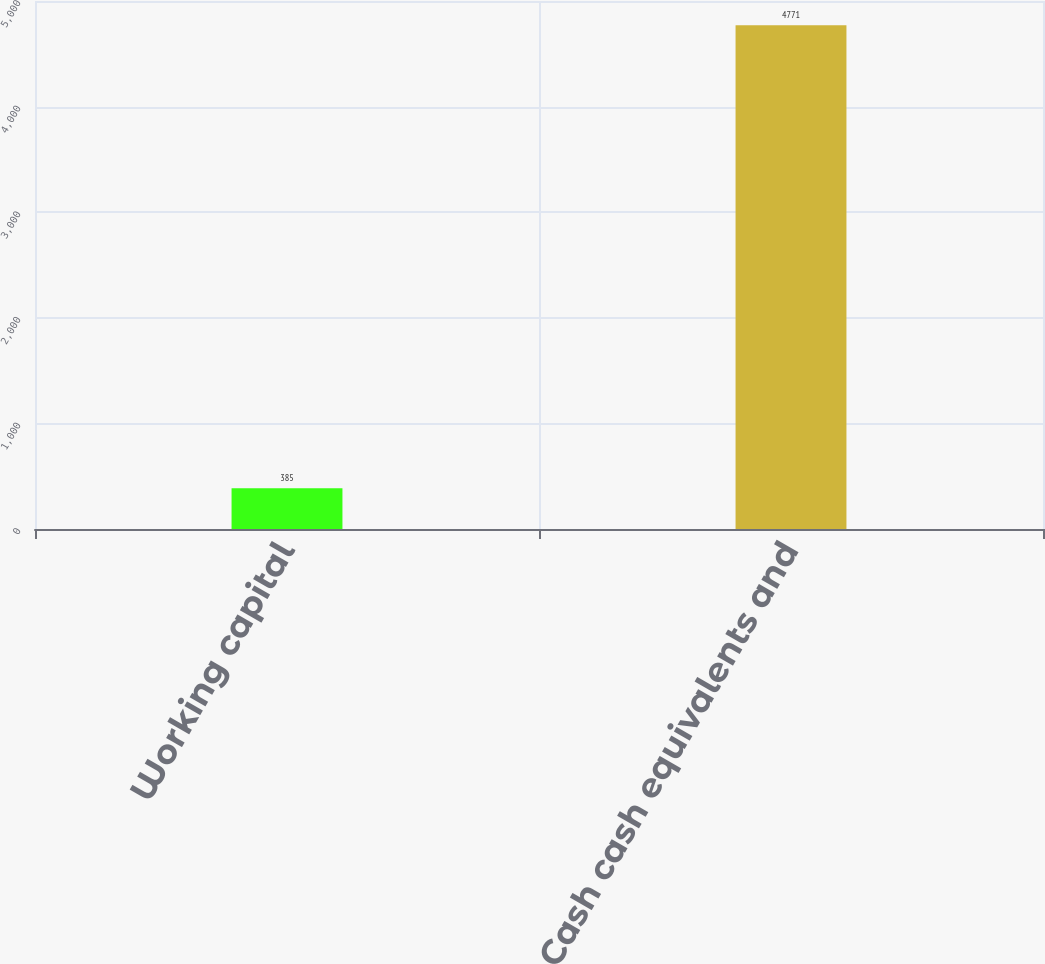<chart> <loc_0><loc_0><loc_500><loc_500><bar_chart><fcel>Working capital<fcel>Cash cash equivalents and<nl><fcel>385<fcel>4771<nl></chart> 